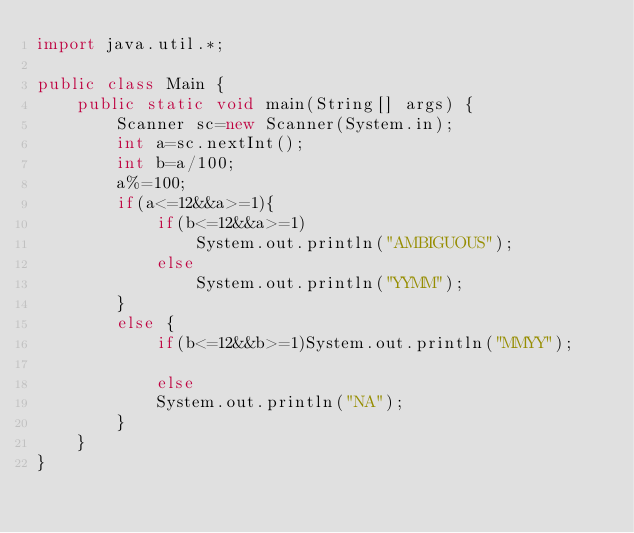Convert code to text. <code><loc_0><loc_0><loc_500><loc_500><_Java_>import java.util.*;

public class Main {
    public static void main(String[] args) {
        Scanner sc=new Scanner(System.in);
        int a=sc.nextInt();
        int b=a/100;
        a%=100;
        if(a<=12&&a>=1){
            if(b<=12&&a>=1)
                System.out.println("AMBIGUOUS");
            else
                System.out.println("YYMM");
        }
        else {
            if(b<=12&&b>=1)System.out.println("MMYY");
            
            else
            System.out.println("NA");
        }
    }
}
</code> 